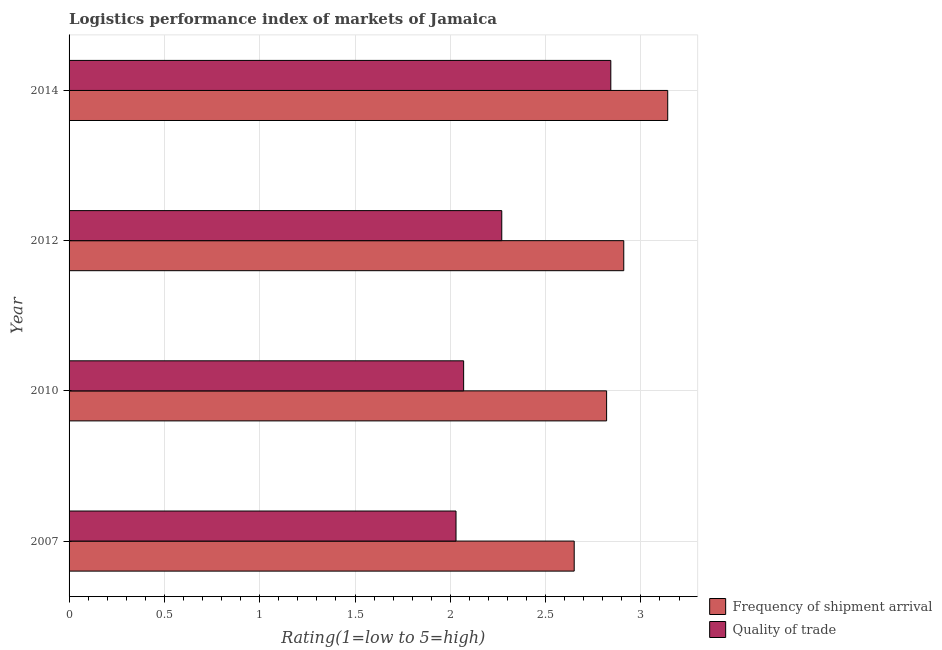How many different coloured bars are there?
Offer a very short reply. 2. Are the number of bars on each tick of the Y-axis equal?
Ensure brevity in your answer.  Yes. How many bars are there on the 3rd tick from the bottom?
Make the answer very short. 2. What is the lpi of frequency of shipment arrival in 2014?
Provide a succinct answer. 3.14. Across all years, what is the maximum lpi quality of trade?
Your answer should be compact. 2.84. Across all years, what is the minimum lpi quality of trade?
Offer a terse response. 2.03. What is the total lpi of frequency of shipment arrival in the graph?
Offer a terse response. 11.52. What is the difference between the lpi of frequency of shipment arrival in 2007 and that in 2012?
Give a very brief answer. -0.26. What is the difference between the lpi of frequency of shipment arrival in 2010 and the lpi quality of trade in 2012?
Provide a short and direct response. 0.55. What is the average lpi of frequency of shipment arrival per year?
Give a very brief answer. 2.88. In the year 2012, what is the difference between the lpi quality of trade and lpi of frequency of shipment arrival?
Your answer should be compact. -0.64. What is the ratio of the lpi of frequency of shipment arrival in 2010 to that in 2012?
Offer a terse response. 0.97. Is the lpi quality of trade in 2007 less than that in 2012?
Make the answer very short. Yes. What is the difference between the highest and the second highest lpi of frequency of shipment arrival?
Provide a succinct answer. 0.23. What is the difference between the highest and the lowest lpi quality of trade?
Ensure brevity in your answer.  0.81. In how many years, is the lpi quality of trade greater than the average lpi quality of trade taken over all years?
Your response must be concise. 1. Is the sum of the lpi quality of trade in 2007 and 2010 greater than the maximum lpi of frequency of shipment arrival across all years?
Your answer should be compact. Yes. What does the 2nd bar from the top in 2012 represents?
Your answer should be very brief. Frequency of shipment arrival. What does the 1st bar from the bottom in 2007 represents?
Offer a terse response. Frequency of shipment arrival. How many bars are there?
Provide a succinct answer. 8. Are the values on the major ticks of X-axis written in scientific E-notation?
Keep it short and to the point. No. Does the graph contain any zero values?
Offer a terse response. No. Where does the legend appear in the graph?
Offer a terse response. Bottom right. What is the title of the graph?
Your answer should be compact. Logistics performance index of markets of Jamaica. What is the label or title of the X-axis?
Keep it short and to the point. Rating(1=low to 5=high). What is the Rating(1=low to 5=high) of Frequency of shipment arrival in 2007?
Offer a terse response. 2.65. What is the Rating(1=low to 5=high) in Quality of trade in 2007?
Make the answer very short. 2.03. What is the Rating(1=low to 5=high) of Frequency of shipment arrival in 2010?
Your response must be concise. 2.82. What is the Rating(1=low to 5=high) in Quality of trade in 2010?
Provide a short and direct response. 2.07. What is the Rating(1=low to 5=high) of Frequency of shipment arrival in 2012?
Keep it short and to the point. 2.91. What is the Rating(1=low to 5=high) of Quality of trade in 2012?
Offer a very short reply. 2.27. What is the Rating(1=low to 5=high) in Frequency of shipment arrival in 2014?
Your answer should be very brief. 3.14. What is the Rating(1=low to 5=high) of Quality of trade in 2014?
Your response must be concise. 2.84. Across all years, what is the maximum Rating(1=low to 5=high) in Frequency of shipment arrival?
Give a very brief answer. 3.14. Across all years, what is the maximum Rating(1=low to 5=high) of Quality of trade?
Your response must be concise. 2.84. Across all years, what is the minimum Rating(1=low to 5=high) of Frequency of shipment arrival?
Your answer should be compact. 2.65. Across all years, what is the minimum Rating(1=low to 5=high) in Quality of trade?
Your answer should be very brief. 2.03. What is the total Rating(1=low to 5=high) in Frequency of shipment arrival in the graph?
Provide a succinct answer. 11.52. What is the total Rating(1=low to 5=high) of Quality of trade in the graph?
Offer a terse response. 9.21. What is the difference between the Rating(1=low to 5=high) of Frequency of shipment arrival in 2007 and that in 2010?
Keep it short and to the point. -0.17. What is the difference between the Rating(1=low to 5=high) in Quality of trade in 2007 and that in 2010?
Offer a very short reply. -0.04. What is the difference between the Rating(1=low to 5=high) of Frequency of shipment arrival in 2007 and that in 2012?
Provide a succinct answer. -0.26. What is the difference between the Rating(1=low to 5=high) of Quality of trade in 2007 and that in 2012?
Offer a very short reply. -0.24. What is the difference between the Rating(1=low to 5=high) of Frequency of shipment arrival in 2007 and that in 2014?
Provide a succinct answer. -0.49. What is the difference between the Rating(1=low to 5=high) of Quality of trade in 2007 and that in 2014?
Offer a terse response. -0.81. What is the difference between the Rating(1=low to 5=high) of Frequency of shipment arrival in 2010 and that in 2012?
Offer a very short reply. -0.09. What is the difference between the Rating(1=low to 5=high) of Frequency of shipment arrival in 2010 and that in 2014?
Provide a short and direct response. -0.32. What is the difference between the Rating(1=low to 5=high) of Quality of trade in 2010 and that in 2014?
Your answer should be very brief. -0.77. What is the difference between the Rating(1=low to 5=high) of Frequency of shipment arrival in 2012 and that in 2014?
Your response must be concise. -0.23. What is the difference between the Rating(1=low to 5=high) of Quality of trade in 2012 and that in 2014?
Your answer should be compact. -0.57. What is the difference between the Rating(1=low to 5=high) in Frequency of shipment arrival in 2007 and the Rating(1=low to 5=high) in Quality of trade in 2010?
Offer a very short reply. 0.58. What is the difference between the Rating(1=low to 5=high) of Frequency of shipment arrival in 2007 and the Rating(1=low to 5=high) of Quality of trade in 2012?
Make the answer very short. 0.38. What is the difference between the Rating(1=low to 5=high) of Frequency of shipment arrival in 2007 and the Rating(1=low to 5=high) of Quality of trade in 2014?
Your answer should be very brief. -0.19. What is the difference between the Rating(1=low to 5=high) of Frequency of shipment arrival in 2010 and the Rating(1=low to 5=high) of Quality of trade in 2012?
Offer a very short reply. 0.55. What is the difference between the Rating(1=low to 5=high) of Frequency of shipment arrival in 2010 and the Rating(1=low to 5=high) of Quality of trade in 2014?
Provide a short and direct response. -0.02. What is the difference between the Rating(1=low to 5=high) in Frequency of shipment arrival in 2012 and the Rating(1=low to 5=high) in Quality of trade in 2014?
Provide a succinct answer. 0.07. What is the average Rating(1=low to 5=high) in Frequency of shipment arrival per year?
Your response must be concise. 2.88. What is the average Rating(1=low to 5=high) of Quality of trade per year?
Your response must be concise. 2.3. In the year 2007, what is the difference between the Rating(1=low to 5=high) in Frequency of shipment arrival and Rating(1=low to 5=high) in Quality of trade?
Your answer should be compact. 0.62. In the year 2010, what is the difference between the Rating(1=low to 5=high) in Frequency of shipment arrival and Rating(1=low to 5=high) in Quality of trade?
Give a very brief answer. 0.75. In the year 2012, what is the difference between the Rating(1=low to 5=high) of Frequency of shipment arrival and Rating(1=low to 5=high) of Quality of trade?
Offer a terse response. 0.64. In the year 2014, what is the difference between the Rating(1=low to 5=high) in Frequency of shipment arrival and Rating(1=low to 5=high) in Quality of trade?
Provide a succinct answer. 0.3. What is the ratio of the Rating(1=low to 5=high) of Frequency of shipment arrival in 2007 to that in 2010?
Keep it short and to the point. 0.94. What is the ratio of the Rating(1=low to 5=high) in Quality of trade in 2007 to that in 2010?
Make the answer very short. 0.98. What is the ratio of the Rating(1=low to 5=high) in Frequency of shipment arrival in 2007 to that in 2012?
Make the answer very short. 0.91. What is the ratio of the Rating(1=low to 5=high) of Quality of trade in 2007 to that in 2012?
Your answer should be very brief. 0.89. What is the ratio of the Rating(1=low to 5=high) of Frequency of shipment arrival in 2007 to that in 2014?
Offer a very short reply. 0.84. What is the ratio of the Rating(1=low to 5=high) in Quality of trade in 2007 to that in 2014?
Offer a terse response. 0.71. What is the ratio of the Rating(1=low to 5=high) in Frequency of shipment arrival in 2010 to that in 2012?
Offer a terse response. 0.97. What is the ratio of the Rating(1=low to 5=high) in Quality of trade in 2010 to that in 2012?
Ensure brevity in your answer.  0.91. What is the ratio of the Rating(1=low to 5=high) of Frequency of shipment arrival in 2010 to that in 2014?
Give a very brief answer. 0.9. What is the ratio of the Rating(1=low to 5=high) of Quality of trade in 2010 to that in 2014?
Ensure brevity in your answer.  0.73. What is the ratio of the Rating(1=low to 5=high) in Frequency of shipment arrival in 2012 to that in 2014?
Give a very brief answer. 0.93. What is the ratio of the Rating(1=low to 5=high) of Quality of trade in 2012 to that in 2014?
Keep it short and to the point. 0.8. What is the difference between the highest and the second highest Rating(1=low to 5=high) of Frequency of shipment arrival?
Provide a succinct answer. 0.23. What is the difference between the highest and the second highest Rating(1=low to 5=high) of Quality of trade?
Offer a terse response. 0.57. What is the difference between the highest and the lowest Rating(1=low to 5=high) in Frequency of shipment arrival?
Your response must be concise. 0.49. What is the difference between the highest and the lowest Rating(1=low to 5=high) of Quality of trade?
Provide a succinct answer. 0.81. 